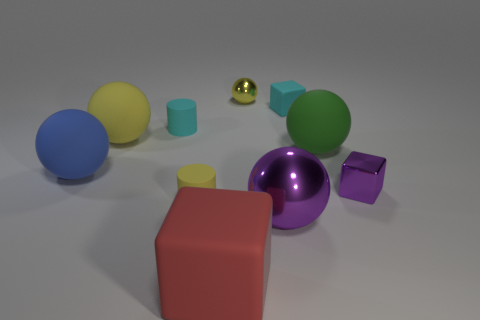There is a small metallic object to the right of the big shiny ball; is its color the same as the metal ball that is in front of the large yellow matte thing?
Provide a short and direct response. Yes. The tiny object that is both to the left of the small cyan matte block and behind the tiny cyan cylinder is what color?
Offer a terse response. Yellow. What number of red rubber blocks have the same size as the green sphere?
Offer a terse response. 1. The tiny metal thing that is in front of the large thing that is to the left of the big yellow matte thing is what shape?
Keep it short and to the point. Cube. There is a small cyan rubber object that is on the left side of the purple thing on the left side of the large matte object that is right of the tiny ball; what shape is it?
Offer a very short reply. Cylinder. What number of other large shiny objects have the same shape as the big blue thing?
Provide a succinct answer. 1. How many green things are behind the yellow thing that is right of the red block?
Ensure brevity in your answer.  0. What number of metal things are either big blue balls or big yellow balls?
Provide a succinct answer. 0. Is there a yellow ball made of the same material as the big purple object?
Give a very brief answer. Yes. How many objects are shiny objects behind the green ball or large matte spheres to the left of the green object?
Your response must be concise. 3. 